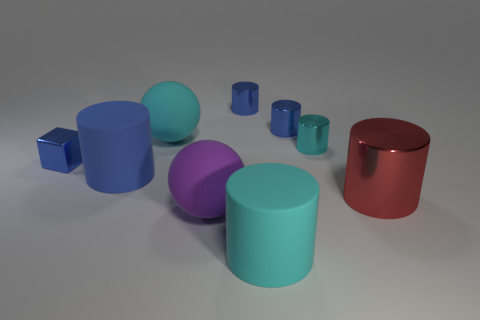Add 1 tiny blue things. How many objects exist? 10 Subtract all cyan cylinders. How many cylinders are left? 4 Subtract all cyan cylinders. How many cylinders are left? 4 Subtract 1 blocks. How many blocks are left? 0 Subtract all blocks. How many objects are left? 8 Subtract all blue balls. Subtract all purple cylinders. How many balls are left? 2 Subtract all red cylinders. How many red spheres are left? 0 Add 4 small blue cylinders. How many small blue cylinders are left? 6 Add 8 large cyan cubes. How many large cyan cubes exist? 8 Subtract 0 blue spheres. How many objects are left? 9 